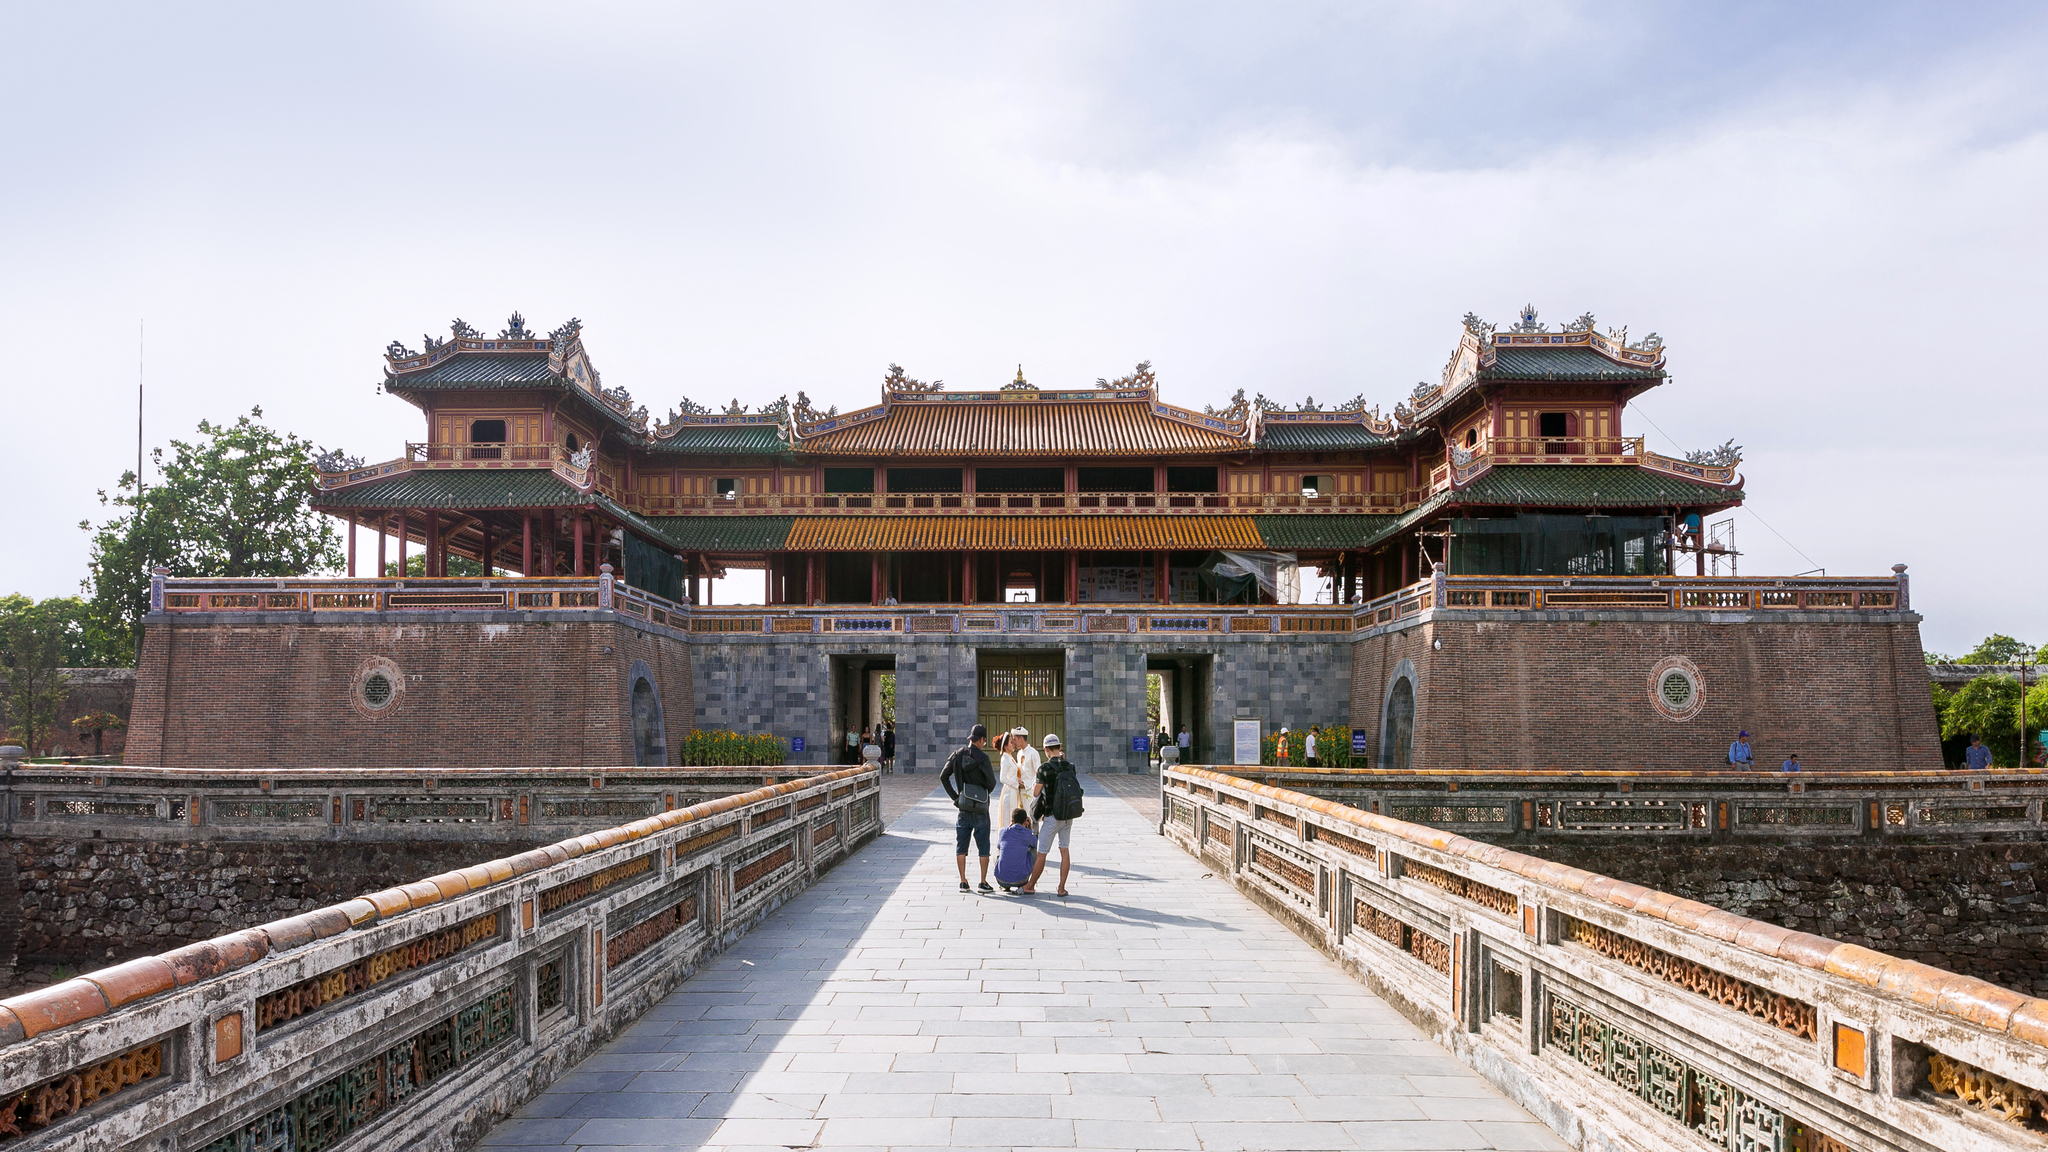Imagine you are witnessing a festival being held at this citadel. Describe the scene. The festival at the Imperial Citadel is a vibrant celebration of cultural heritage. The grand structure is adorned with colorful banners and lanterns that sway gently with the breeze. Traditional music fills the air, played on ancient instruments, creating a lively yet nostalgic ambiance. The courtyards are bustling with people dressed in beautiful traditional attire, participating in various activities such as dance performances, calligraphy demonstrations, and martial arts shows. Stalls are set up offering a variety of traditional foods and crafts. There is a sense of joy and community spirit, as visitors of all ages partake in the festivities, celebrating the rich history and culture that the citadel has stood witness to for centuries. 